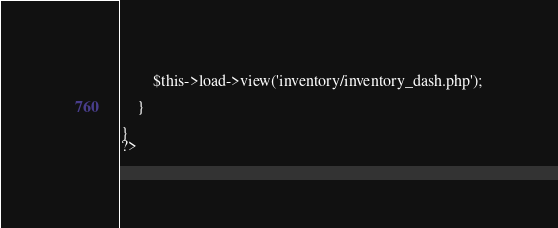Convert code to text. <code><loc_0><loc_0><loc_500><loc_500><_PHP_>		$this->load->view('inventory/inventory_dash.php');
		
	}		
	
}
?></code> 